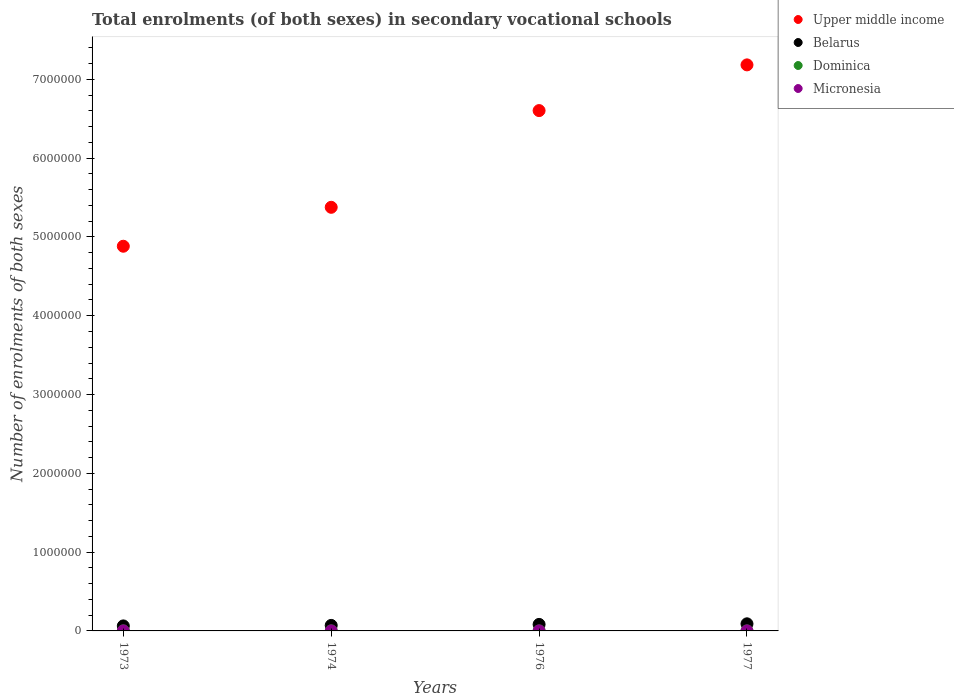Is the number of dotlines equal to the number of legend labels?
Offer a very short reply. Yes. What is the number of enrolments in secondary schools in Upper middle income in 1974?
Your answer should be very brief. 5.38e+06. Across all years, what is the maximum number of enrolments in secondary schools in Micronesia?
Offer a terse response. 318. Across all years, what is the minimum number of enrolments in secondary schools in Dominica?
Your response must be concise. 591. In which year was the number of enrolments in secondary schools in Belarus minimum?
Ensure brevity in your answer.  1973. What is the total number of enrolments in secondary schools in Dominica in the graph?
Your answer should be compact. 3433. What is the difference between the number of enrolments in secondary schools in Dominica in 1974 and that in 1977?
Keep it short and to the point. 415. What is the difference between the number of enrolments in secondary schools in Upper middle income in 1974 and the number of enrolments in secondary schools in Micronesia in 1977?
Your answer should be very brief. 5.38e+06. What is the average number of enrolments in secondary schools in Belarus per year?
Your answer should be very brief. 7.66e+04. In the year 1974, what is the difference between the number of enrolments in secondary schools in Micronesia and number of enrolments in secondary schools in Upper middle income?
Offer a terse response. -5.38e+06. What is the ratio of the number of enrolments in secondary schools in Upper middle income in 1973 to that in 1977?
Your answer should be very brief. 0.68. Is the difference between the number of enrolments in secondary schools in Micronesia in 1976 and 1977 greater than the difference between the number of enrolments in secondary schools in Upper middle income in 1976 and 1977?
Your answer should be compact. Yes. What is the difference between the highest and the second highest number of enrolments in secondary schools in Dominica?
Your response must be concise. 164. What is the difference between the highest and the lowest number of enrolments in secondary schools in Micronesia?
Offer a terse response. 96. In how many years, is the number of enrolments in secondary schools in Belarus greater than the average number of enrolments in secondary schools in Belarus taken over all years?
Give a very brief answer. 2. Is it the case that in every year, the sum of the number of enrolments in secondary schools in Micronesia and number of enrolments in secondary schools in Dominica  is greater than the sum of number of enrolments in secondary schools in Belarus and number of enrolments in secondary schools in Upper middle income?
Your response must be concise. No. Does the number of enrolments in secondary schools in Upper middle income monotonically increase over the years?
Provide a short and direct response. Yes. Does the graph contain any zero values?
Make the answer very short. No. Does the graph contain grids?
Make the answer very short. No. How many legend labels are there?
Offer a very short reply. 4. How are the legend labels stacked?
Your response must be concise. Vertical. What is the title of the graph?
Your answer should be very brief. Total enrolments (of both sexes) in secondary vocational schools. Does "Sub-Saharan Africa (developing only)" appear as one of the legend labels in the graph?
Your response must be concise. No. What is the label or title of the X-axis?
Offer a terse response. Years. What is the label or title of the Y-axis?
Your answer should be compact. Number of enrolments of both sexes. What is the Number of enrolments of both sexes in Upper middle income in 1973?
Provide a succinct answer. 4.88e+06. What is the Number of enrolments of both sexes in Belarus in 1973?
Provide a succinct answer. 6.36e+04. What is the Number of enrolments of both sexes of Dominica in 1973?
Ensure brevity in your answer.  1195. What is the Number of enrolments of both sexes in Micronesia in 1973?
Your answer should be very brief. 226. What is the Number of enrolments of both sexes in Upper middle income in 1974?
Ensure brevity in your answer.  5.38e+06. What is the Number of enrolments of both sexes in Belarus in 1974?
Ensure brevity in your answer.  6.99e+04. What is the Number of enrolments of both sexes of Dominica in 1974?
Your answer should be very brief. 1031. What is the Number of enrolments of both sexes in Micronesia in 1974?
Your answer should be compact. 222. What is the Number of enrolments of both sexes in Upper middle income in 1976?
Make the answer very short. 6.60e+06. What is the Number of enrolments of both sexes in Belarus in 1976?
Your response must be concise. 8.26e+04. What is the Number of enrolments of both sexes in Dominica in 1976?
Ensure brevity in your answer.  591. What is the Number of enrolments of both sexes in Micronesia in 1976?
Make the answer very short. 318. What is the Number of enrolments of both sexes in Upper middle income in 1977?
Give a very brief answer. 7.18e+06. What is the Number of enrolments of both sexes in Belarus in 1977?
Offer a very short reply. 9.02e+04. What is the Number of enrolments of both sexes of Dominica in 1977?
Your response must be concise. 616. What is the Number of enrolments of both sexes in Micronesia in 1977?
Your answer should be very brief. 318. Across all years, what is the maximum Number of enrolments of both sexes in Upper middle income?
Keep it short and to the point. 7.18e+06. Across all years, what is the maximum Number of enrolments of both sexes in Belarus?
Your answer should be very brief. 9.02e+04. Across all years, what is the maximum Number of enrolments of both sexes in Dominica?
Your answer should be very brief. 1195. Across all years, what is the maximum Number of enrolments of both sexes of Micronesia?
Offer a terse response. 318. Across all years, what is the minimum Number of enrolments of both sexes of Upper middle income?
Your answer should be very brief. 4.88e+06. Across all years, what is the minimum Number of enrolments of both sexes in Belarus?
Your response must be concise. 6.36e+04. Across all years, what is the minimum Number of enrolments of both sexes of Dominica?
Your answer should be compact. 591. Across all years, what is the minimum Number of enrolments of both sexes in Micronesia?
Give a very brief answer. 222. What is the total Number of enrolments of both sexes of Upper middle income in the graph?
Make the answer very short. 2.40e+07. What is the total Number of enrolments of both sexes of Belarus in the graph?
Give a very brief answer. 3.06e+05. What is the total Number of enrolments of both sexes of Dominica in the graph?
Make the answer very short. 3433. What is the total Number of enrolments of both sexes in Micronesia in the graph?
Provide a short and direct response. 1084. What is the difference between the Number of enrolments of both sexes of Upper middle income in 1973 and that in 1974?
Provide a short and direct response. -4.94e+05. What is the difference between the Number of enrolments of both sexes of Belarus in 1973 and that in 1974?
Provide a short and direct response. -6340. What is the difference between the Number of enrolments of both sexes of Dominica in 1973 and that in 1974?
Provide a succinct answer. 164. What is the difference between the Number of enrolments of both sexes in Micronesia in 1973 and that in 1974?
Offer a terse response. 4. What is the difference between the Number of enrolments of both sexes of Upper middle income in 1973 and that in 1976?
Offer a terse response. -1.72e+06. What is the difference between the Number of enrolments of both sexes of Belarus in 1973 and that in 1976?
Your answer should be compact. -1.90e+04. What is the difference between the Number of enrolments of both sexes in Dominica in 1973 and that in 1976?
Keep it short and to the point. 604. What is the difference between the Number of enrolments of both sexes in Micronesia in 1973 and that in 1976?
Your answer should be very brief. -92. What is the difference between the Number of enrolments of both sexes of Upper middle income in 1973 and that in 1977?
Keep it short and to the point. -2.30e+06. What is the difference between the Number of enrolments of both sexes of Belarus in 1973 and that in 1977?
Provide a succinct answer. -2.66e+04. What is the difference between the Number of enrolments of both sexes of Dominica in 1973 and that in 1977?
Offer a terse response. 579. What is the difference between the Number of enrolments of both sexes of Micronesia in 1973 and that in 1977?
Your answer should be very brief. -92. What is the difference between the Number of enrolments of both sexes of Upper middle income in 1974 and that in 1976?
Keep it short and to the point. -1.23e+06. What is the difference between the Number of enrolments of both sexes of Belarus in 1974 and that in 1976?
Keep it short and to the point. -1.27e+04. What is the difference between the Number of enrolments of both sexes of Dominica in 1974 and that in 1976?
Offer a very short reply. 440. What is the difference between the Number of enrolments of both sexes of Micronesia in 1974 and that in 1976?
Your answer should be very brief. -96. What is the difference between the Number of enrolments of both sexes of Upper middle income in 1974 and that in 1977?
Give a very brief answer. -1.81e+06. What is the difference between the Number of enrolments of both sexes in Belarus in 1974 and that in 1977?
Offer a terse response. -2.02e+04. What is the difference between the Number of enrolments of both sexes in Dominica in 1974 and that in 1977?
Your answer should be compact. 415. What is the difference between the Number of enrolments of both sexes of Micronesia in 1974 and that in 1977?
Ensure brevity in your answer.  -96. What is the difference between the Number of enrolments of both sexes in Upper middle income in 1976 and that in 1977?
Your answer should be compact. -5.80e+05. What is the difference between the Number of enrolments of both sexes of Belarus in 1976 and that in 1977?
Give a very brief answer. -7567. What is the difference between the Number of enrolments of both sexes in Dominica in 1976 and that in 1977?
Offer a very short reply. -25. What is the difference between the Number of enrolments of both sexes in Micronesia in 1976 and that in 1977?
Offer a terse response. 0. What is the difference between the Number of enrolments of both sexes of Upper middle income in 1973 and the Number of enrolments of both sexes of Belarus in 1974?
Your answer should be compact. 4.81e+06. What is the difference between the Number of enrolments of both sexes of Upper middle income in 1973 and the Number of enrolments of both sexes of Dominica in 1974?
Offer a very short reply. 4.88e+06. What is the difference between the Number of enrolments of both sexes in Upper middle income in 1973 and the Number of enrolments of both sexes in Micronesia in 1974?
Keep it short and to the point. 4.88e+06. What is the difference between the Number of enrolments of both sexes of Belarus in 1973 and the Number of enrolments of both sexes of Dominica in 1974?
Give a very brief answer. 6.25e+04. What is the difference between the Number of enrolments of both sexes in Belarus in 1973 and the Number of enrolments of both sexes in Micronesia in 1974?
Your answer should be compact. 6.34e+04. What is the difference between the Number of enrolments of both sexes in Dominica in 1973 and the Number of enrolments of both sexes in Micronesia in 1974?
Offer a very short reply. 973. What is the difference between the Number of enrolments of both sexes of Upper middle income in 1973 and the Number of enrolments of both sexes of Belarus in 1976?
Offer a terse response. 4.80e+06. What is the difference between the Number of enrolments of both sexes in Upper middle income in 1973 and the Number of enrolments of both sexes in Dominica in 1976?
Ensure brevity in your answer.  4.88e+06. What is the difference between the Number of enrolments of both sexes in Upper middle income in 1973 and the Number of enrolments of both sexes in Micronesia in 1976?
Offer a terse response. 4.88e+06. What is the difference between the Number of enrolments of both sexes in Belarus in 1973 and the Number of enrolments of both sexes in Dominica in 1976?
Provide a short and direct response. 6.30e+04. What is the difference between the Number of enrolments of both sexes in Belarus in 1973 and the Number of enrolments of both sexes in Micronesia in 1976?
Ensure brevity in your answer.  6.33e+04. What is the difference between the Number of enrolments of both sexes of Dominica in 1973 and the Number of enrolments of both sexes of Micronesia in 1976?
Keep it short and to the point. 877. What is the difference between the Number of enrolments of both sexes in Upper middle income in 1973 and the Number of enrolments of both sexes in Belarus in 1977?
Provide a short and direct response. 4.79e+06. What is the difference between the Number of enrolments of both sexes of Upper middle income in 1973 and the Number of enrolments of both sexes of Dominica in 1977?
Your answer should be compact. 4.88e+06. What is the difference between the Number of enrolments of both sexes of Upper middle income in 1973 and the Number of enrolments of both sexes of Micronesia in 1977?
Provide a succinct answer. 4.88e+06. What is the difference between the Number of enrolments of both sexes of Belarus in 1973 and the Number of enrolments of both sexes of Dominica in 1977?
Your answer should be very brief. 6.30e+04. What is the difference between the Number of enrolments of both sexes in Belarus in 1973 and the Number of enrolments of both sexes in Micronesia in 1977?
Make the answer very short. 6.33e+04. What is the difference between the Number of enrolments of both sexes in Dominica in 1973 and the Number of enrolments of both sexes in Micronesia in 1977?
Offer a very short reply. 877. What is the difference between the Number of enrolments of both sexes in Upper middle income in 1974 and the Number of enrolments of both sexes in Belarus in 1976?
Make the answer very short. 5.29e+06. What is the difference between the Number of enrolments of both sexes of Upper middle income in 1974 and the Number of enrolments of both sexes of Dominica in 1976?
Your answer should be compact. 5.38e+06. What is the difference between the Number of enrolments of both sexes in Upper middle income in 1974 and the Number of enrolments of both sexes in Micronesia in 1976?
Your answer should be compact. 5.38e+06. What is the difference between the Number of enrolments of both sexes of Belarus in 1974 and the Number of enrolments of both sexes of Dominica in 1976?
Ensure brevity in your answer.  6.93e+04. What is the difference between the Number of enrolments of both sexes in Belarus in 1974 and the Number of enrolments of both sexes in Micronesia in 1976?
Your answer should be very brief. 6.96e+04. What is the difference between the Number of enrolments of both sexes in Dominica in 1974 and the Number of enrolments of both sexes in Micronesia in 1976?
Give a very brief answer. 713. What is the difference between the Number of enrolments of both sexes in Upper middle income in 1974 and the Number of enrolments of both sexes in Belarus in 1977?
Ensure brevity in your answer.  5.29e+06. What is the difference between the Number of enrolments of both sexes of Upper middle income in 1974 and the Number of enrolments of both sexes of Dominica in 1977?
Keep it short and to the point. 5.38e+06. What is the difference between the Number of enrolments of both sexes of Upper middle income in 1974 and the Number of enrolments of both sexes of Micronesia in 1977?
Offer a very short reply. 5.38e+06. What is the difference between the Number of enrolments of both sexes of Belarus in 1974 and the Number of enrolments of both sexes of Dominica in 1977?
Provide a succinct answer. 6.93e+04. What is the difference between the Number of enrolments of both sexes of Belarus in 1974 and the Number of enrolments of both sexes of Micronesia in 1977?
Provide a short and direct response. 6.96e+04. What is the difference between the Number of enrolments of both sexes in Dominica in 1974 and the Number of enrolments of both sexes in Micronesia in 1977?
Ensure brevity in your answer.  713. What is the difference between the Number of enrolments of both sexes of Upper middle income in 1976 and the Number of enrolments of both sexes of Belarus in 1977?
Provide a succinct answer. 6.51e+06. What is the difference between the Number of enrolments of both sexes of Upper middle income in 1976 and the Number of enrolments of both sexes of Dominica in 1977?
Offer a very short reply. 6.60e+06. What is the difference between the Number of enrolments of both sexes of Upper middle income in 1976 and the Number of enrolments of both sexes of Micronesia in 1977?
Provide a succinct answer. 6.60e+06. What is the difference between the Number of enrolments of both sexes in Belarus in 1976 and the Number of enrolments of both sexes in Dominica in 1977?
Your response must be concise. 8.20e+04. What is the difference between the Number of enrolments of both sexes in Belarus in 1976 and the Number of enrolments of both sexes in Micronesia in 1977?
Make the answer very short. 8.23e+04. What is the difference between the Number of enrolments of both sexes of Dominica in 1976 and the Number of enrolments of both sexes of Micronesia in 1977?
Offer a very short reply. 273. What is the average Number of enrolments of both sexes in Upper middle income per year?
Ensure brevity in your answer.  6.01e+06. What is the average Number of enrolments of both sexes of Belarus per year?
Provide a succinct answer. 7.66e+04. What is the average Number of enrolments of both sexes of Dominica per year?
Provide a succinct answer. 858.25. What is the average Number of enrolments of both sexes in Micronesia per year?
Keep it short and to the point. 271. In the year 1973, what is the difference between the Number of enrolments of both sexes in Upper middle income and Number of enrolments of both sexes in Belarus?
Provide a short and direct response. 4.82e+06. In the year 1973, what is the difference between the Number of enrolments of both sexes in Upper middle income and Number of enrolments of both sexes in Dominica?
Your response must be concise. 4.88e+06. In the year 1973, what is the difference between the Number of enrolments of both sexes in Upper middle income and Number of enrolments of both sexes in Micronesia?
Your response must be concise. 4.88e+06. In the year 1973, what is the difference between the Number of enrolments of both sexes in Belarus and Number of enrolments of both sexes in Dominica?
Your response must be concise. 6.24e+04. In the year 1973, what is the difference between the Number of enrolments of both sexes in Belarus and Number of enrolments of both sexes in Micronesia?
Offer a terse response. 6.34e+04. In the year 1973, what is the difference between the Number of enrolments of both sexes of Dominica and Number of enrolments of both sexes of Micronesia?
Offer a very short reply. 969. In the year 1974, what is the difference between the Number of enrolments of both sexes in Upper middle income and Number of enrolments of both sexes in Belarus?
Offer a very short reply. 5.31e+06. In the year 1974, what is the difference between the Number of enrolments of both sexes of Upper middle income and Number of enrolments of both sexes of Dominica?
Keep it short and to the point. 5.38e+06. In the year 1974, what is the difference between the Number of enrolments of both sexes of Upper middle income and Number of enrolments of both sexes of Micronesia?
Your answer should be compact. 5.38e+06. In the year 1974, what is the difference between the Number of enrolments of both sexes in Belarus and Number of enrolments of both sexes in Dominica?
Provide a succinct answer. 6.89e+04. In the year 1974, what is the difference between the Number of enrolments of both sexes in Belarus and Number of enrolments of both sexes in Micronesia?
Provide a succinct answer. 6.97e+04. In the year 1974, what is the difference between the Number of enrolments of both sexes of Dominica and Number of enrolments of both sexes of Micronesia?
Keep it short and to the point. 809. In the year 1976, what is the difference between the Number of enrolments of both sexes in Upper middle income and Number of enrolments of both sexes in Belarus?
Ensure brevity in your answer.  6.52e+06. In the year 1976, what is the difference between the Number of enrolments of both sexes of Upper middle income and Number of enrolments of both sexes of Dominica?
Your answer should be compact. 6.60e+06. In the year 1976, what is the difference between the Number of enrolments of both sexes of Upper middle income and Number of enrolments of both sexes of Micronesia?
Provide a succinct answer. 6.60e+06. In the year 1976, what is the difference between the Number of enrolments of both sexes in Belarus and Number of enrolments of both sexes in Dominica?
Provide a short and direct response. 8.20e+04. In the year 1976, what is the difference between the Number of enrolments of both sexes of Belarus and Number of enrolments of both sexes of Micronesia?
Ensure brevity in your answer.  8.23e+04. In the year 1976, what is the difference between the Number of enrolments of both sexes in Dominica and Number of enrolments of both sexes in Micronesia?
Your response must be concise. 273. In the year 1977, what is the difference between the Number of enrolments of both sexes in Upper middle income and Number of enrolments of both sexes in Belarus?
Offer a very short reply. 7.09e+06. In the year 1977, what is the difference between the Number of enrolments of both sexes in Upper middle income and Number of enrolments of both sexes in Dominica?
Offer a terse response. 7.18e+06. In the year 1977, what is the difference between the Number of enrolments of both sexes of Upper middle income and Number of enrolments of both sexes of Micronesia?
Your response must be concise. 7.18e+06. In the year 1977, what is the difference between the Number of enrolments of both sexes in Belarus and Number of enrolments of both sexes in Dominica?
Make the answer very short. 8.96e+04. In the year 1977, what is the difference between the Number of enrolments of both sexes of Belarus and Number of enrolments of both sexes of Micronesia?
Offer a terse response. 8.98e+04. In the year 1977, what is the difference between the Number of enrolments of both sexes of Dominica and Number of enrolments of both sexes of Micronesia?
Provide a succinct answer. 298. What is the ratio of the Number of enrolments of both sexes in Upper middle income in 1973 to that in 1974?
Provide a succinct answer. 0.91. What is the ratio of the Number of enrolments of both sexes of Belarus in 1973 to that in 1974?
Your answer should be very brief. 0.91. What is the ratio of the Number of enrolments of both sexes of Dominica in 1973 to that in 1974?
Give a very brief answer. 1.16. What is the ratio of the Number of enrolments of both sexes in Upper middle income in 1973 to that in 1976?
Your response must be concise. 0.74. What is the ratio of the Number of enrolments of both sexes of Belarus in 1973 to that in 1976?
Your response must be concise. 0.77. What is the ratio of the Number of enrolments of both sexes of Dominica in 1973 to that in 1976?
Give a very brief answer. 2.02. What is the ratio of the Number of enrolments of both sexes of Micronesia in 1973 to that in 1976?
Offer a very short reply. 0.71. What is the ratio of the Number of enrolments of both sexes of Upper middle income in 1973 to that in 1977?
Your answer should be very brief. 0.68. What is the ratio of the Number of enrolments of both sexes in Belarus in 1973 to that in 1977?
Offer a very short reply. 0.71. What is the ratio of the Number of enrolments of both sexes in Dominica in 1973 to that in 1977?
Make the answer very short. 1.94. What is the ratio of the Number of enrolments of both sexes in Micronesia in 1973 to that in 1977?
Provide a short and direct response. 0.71. What is the ratio of the Number of enrolments of both sexes of Upper middle income in 1974 to that in 1976?
Offer a terse response. 0.81. What is the ratio of the Number of enrolments of both sexes in Belarus in 1974 to that in 1976?
Provide a short and direct response. 0.85. What is the ratio of the Number of enrolments of both sexes of Dominica in 1974 to that in 1976?
Your answer should be very brief. 1.74. What is the ratio of the Number of enrolments of both sexes in Micronesia in 1974 to that in 1976?
Provide a short and direct response. 0.7. What is the ratio of the Number of enrolments of both sexes in Upper middle income in 1974 to that in 1977?
Provide a succinct answer. 0.75. What is the ratio of the Number of enrolments of both sexes of Belarus in 1974 to that in 1977?
Offer a terse response. 0.78. What is the ratio of the Number of enrolments of both sexes in Dominica in 1974 to that in 1977?
Ensure brevity in your answer.  1.67. What is the ratio of the Number of enrolments of both sexes of Micronesia in 1974 to that in 1977?
Keep it short and to the point. 0.7. What is the ratio of the Number of enrolments of both sexes in Upper middle income in 1976 to that in 1977?
Make the answer very short. 0.92. What is the ratio of the Number of enrolments of both sexes in Belarus in 1976 to that in 1977?
Make the answer very short. 0.92. What is the ratio of the Number of enrolments of both sexes of Dominica in 1976 to that in 1977?
Provide a short and direct response. 0.96. What is the ratio of the Number of enrolments of both sexes in Micronesia in 1976 to that in 1977?
Ensure brevity in your answer.  1. What is the difference between the highest and the second highest Number of enrolments of both sexes in Upper middle income?
Offer a terse response. 5.80e+05. What is the difference between the highest and the second highest Number of enrolments of both sexes in Belarus?
Your answer should be very brief. 7567. What is the difference between the highest and the second highest Number of enrolments of both sexes of Dominica?
Give a very brief answer. 164. What is the difference between the highest and the second highest Number of enrolments of both sexes in Micronesia?
Offer a very short reply. 0. What is the difference between the highest and the lowest Number of enrolments of both sexes in Upper middle income?
Your answer should be very brief. 2.30e+06. What is the difference between the highest and the lowest Number of enrolments of both sexes of Belarus?
Offer a terse response. 2.66e+04. What is the difference between the highest and the lowest Number of enrolments of both sexes in Dominica?
Ensure brevity in your answer.  604. What is the difference between the highest and the lowest Number of enrolments of both sexes of Micronesia?
Your response must be concise. 96. 